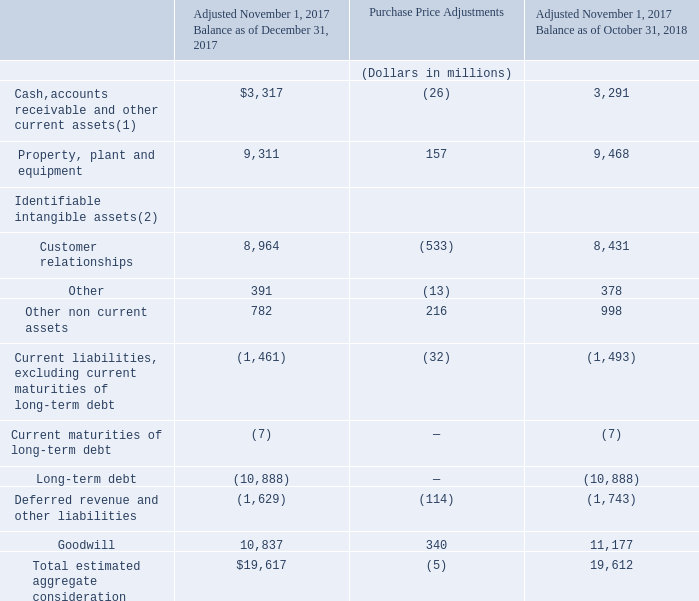The aggregate cash payments required to be paid on or about the closing date were funded with the proceeds of $7.945 billion of term loans and $400 million of funds borrowed under our revolving credit facility together with other available funds, which included $1.825 billion borrowed from Level 3 Parent, LLC. For additional information regarding CenturyLink’s financing of the Level 3 acquisition see Note 7—Long-Term Debt and Credit Facilities.
We recognized the assets and liabilities of Level 3 based on the fair value of the acquired tangible and intangible assets and assumed liabilities of Level 3 as of November 1, 2017, the consummation date of the acquisition, with the excess aggregate consideration recorded as goodwill. The estimation of such fair values and the estimation of lives of depreciable tangible assets and amortizable intangible assets required significant judgment. We completed our final fair value determination during the fourth quarter of 2018, which differed from those reflected in our consolidated financial statements at December 31, 2017.
In connection with receiving approval from the U.S. Department of Justice to complete the Level 3 acquisition we agreed to divest certain Level 3 network assets. All of those assets were sold by December 31, 2018. The proceeds from these sales were included in the proceeds from sale of property, plant and equipment in our consolidated statements of cash flows. No gain or loss was recognized with these transactions.
As of October 31, 2018, the aggregate consideration exceeded the aggregate estimated fair value of the acquired assets and assumed liabilities by $11.2 billion, which we have recognized as goodwill. The goodwill is attributable to strategic benefits, including enhanced financial and operational scale, market diversification and leveraged combined networks that we expect to realize. None of the goodwill associated with this acquisition is deductible for income tax purposes.
The following is our assignment of the aggregate consideration:
(1) Includes accounts receivable, which had a gross contractual value of $884 million on November 1, 2017 and October 31, 2018.
(2) The weighted-average amortization period for the acquired intangible assets is approximately 12.0 years.
On the acquisition date, we assumed Level 3’s contingencies. For more information on our contingencies, see Note 19—Commitments, Contingencies and Other Items.
What do cash, accounts receivable and other current assets include? Accounts receivable, which had a gross contractual value of $884 million on november 1, 2017 and october 31, 2018. What is the weighted-average amortization period for the identifiable intangible assets? 12.0 years. What is goodwill attributable to? Strategic benefits, enhanced financial and operational scale, market diversification, leveraged combined networks. Which period has a larger total estimated aggregate consideration? 19,617>19,612
Answer: december 31, 2017. What is property, plant and equipment expressed as a ratio of the total estimated aggregate consideration under the balance as of December 31, 2017?
Answer scale should be: percent. 9,311/19,617
Answer: 47.46. What is the percentage change in other non currrent assets in 2018?
Answer scale should be: percent. (998-782)/782
Answer: 27.62. 